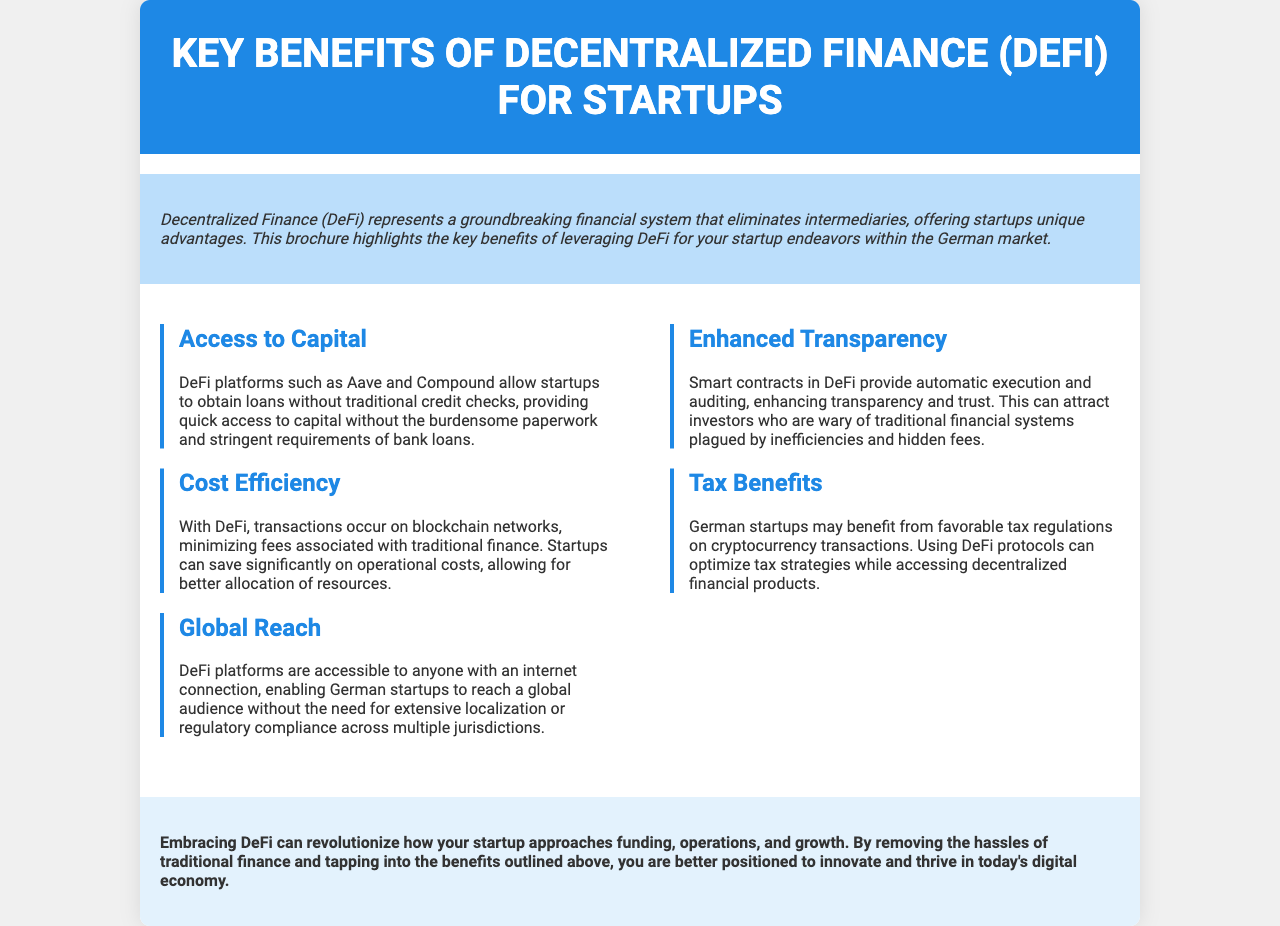what is the title of the brochure? The title of the brochure is mentioned at the top of the document in the header section.
Answer: Key Benefits of Decentralized Finance (DeFi) for Startups what is a key advantage of DeFi platforms like Aave and Compound for startups? The document highlights that startups can obtain loans without traditional credit checks on these platforms.
Answer: Access to Capital how do DeFi platforms enhance transparency? The document explains that smart contracts provide automatic execution and auditing, which increases transparency.
Answer: Smart contracts what are the tax benefits for German startups using DeFi? The text states that they may benefit from favorable tax regulations on cryptocurrency transactions.
Answer: Favorable tax regulations how many key benefits of DeFi for startups are listed in the brochure? The brochure outlines five key benefits of Decentralized Finance for startups.
Answer: Five 